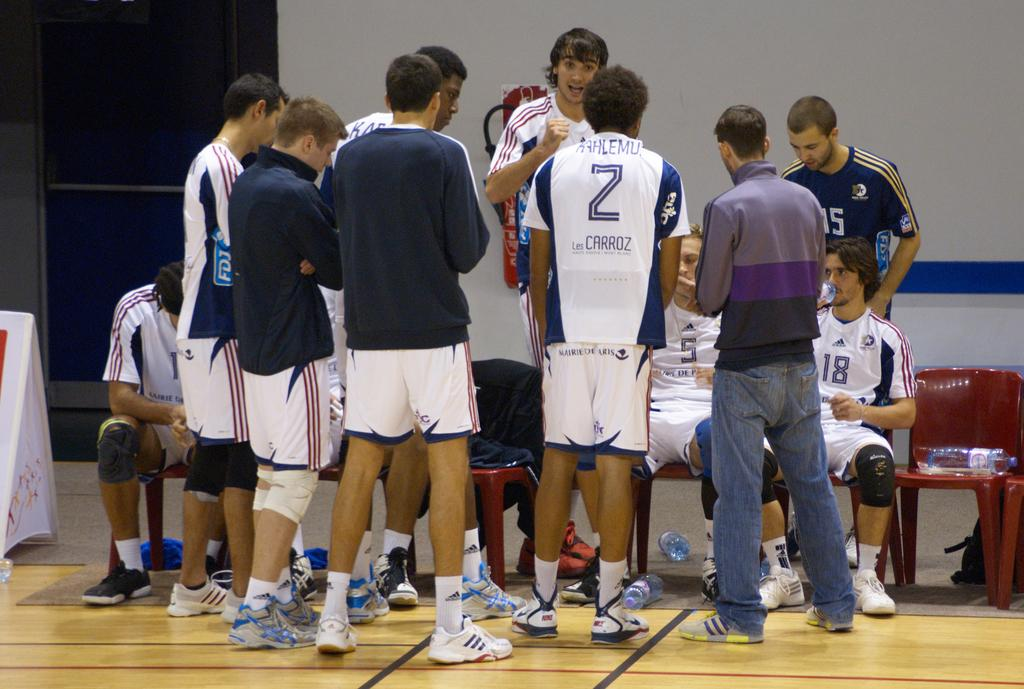<image>
Render a clear and concise summary of the photo. Basketball team in a huddle to discuss the game and a player has the number 2. 